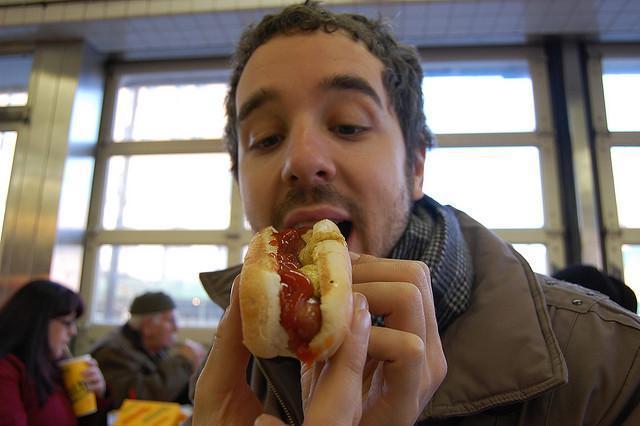What style of food is being served?
Choose the correct response, then elucidate: 'Answer: answer
Rationale: rationale.'
Options: Indian, mexican, italian, american. Answer: american.
Rationale: The person in the foreground is eating a hot dog. 